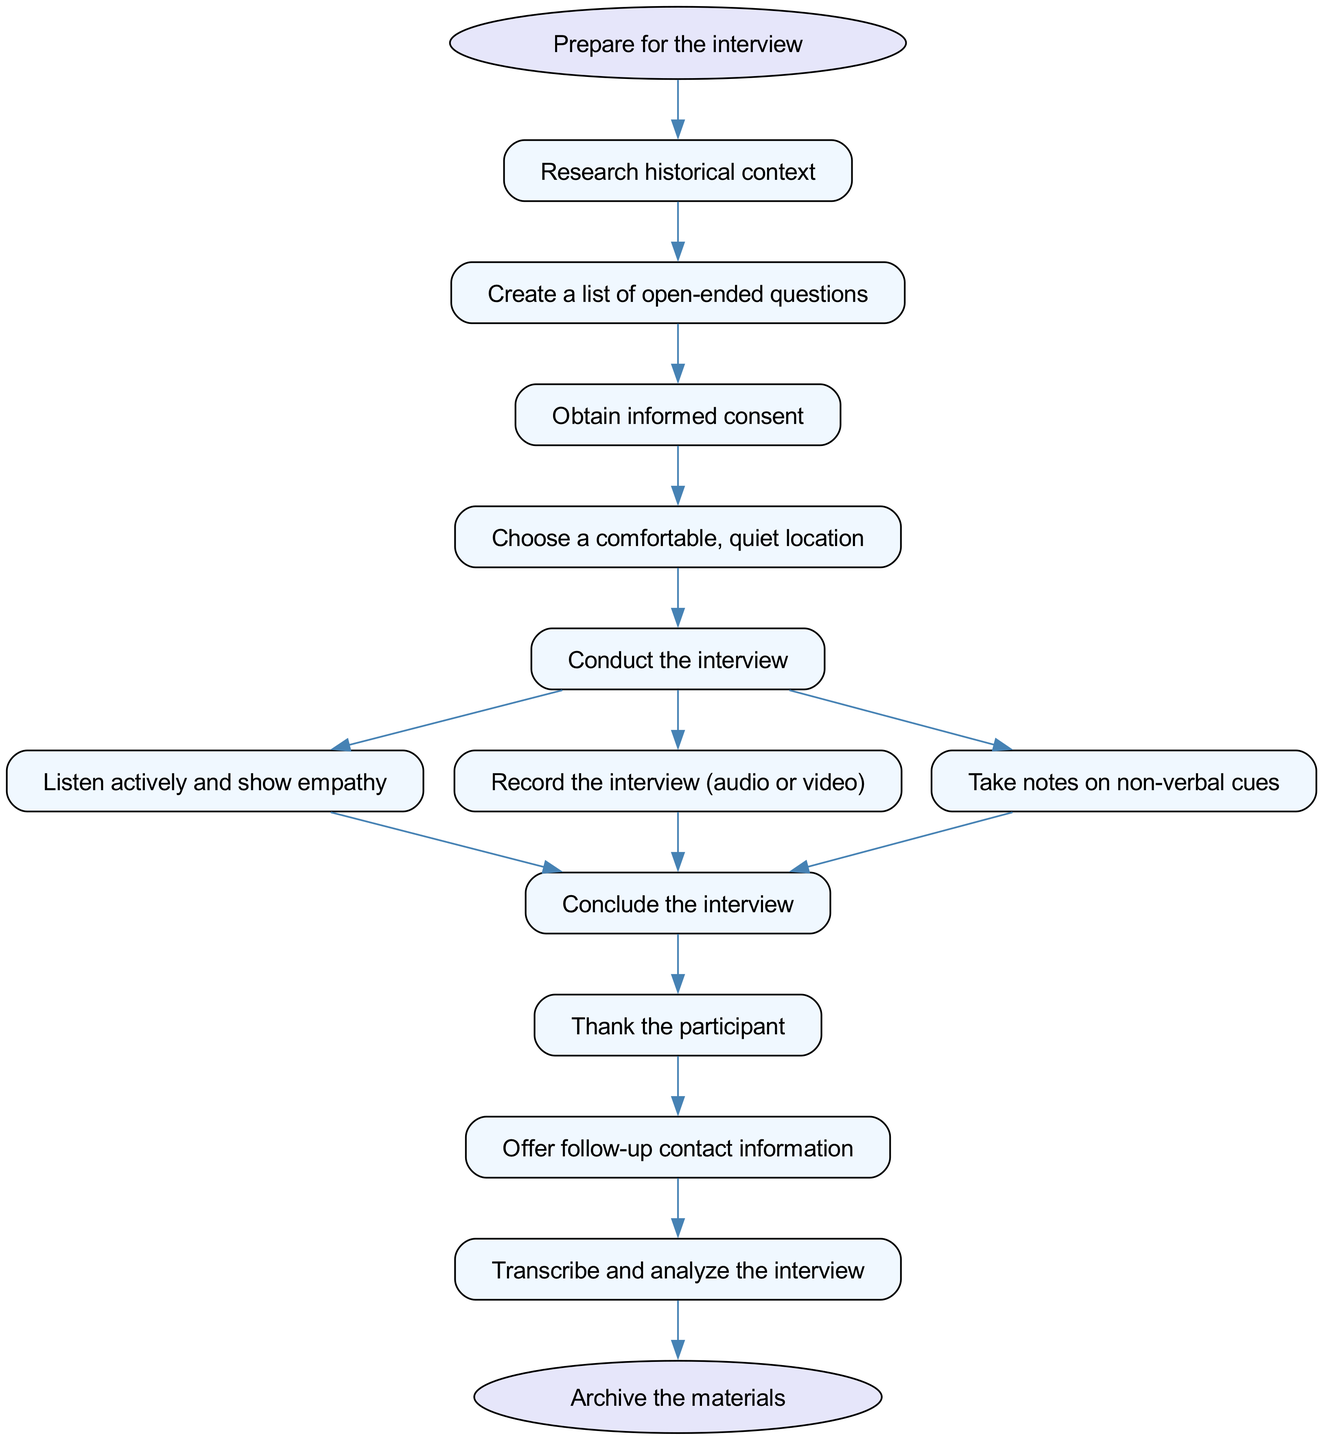What is the first step in the interview process? The diagram shows that the first step after starting is to "Prepare for the interview." Therefore, the initial action is to prepare.
Answer: Prepare for the interview How many nodes are connected directly to "Conduct the interview"? "Conduct the interview" has three direct connections leading to "Listen actively and show empathy," "Record the interview (audio or video)," and "Take notes on non-verbal cues." Counting these gives us three.
Answer: 3 What is required before choosing a location for the interview? According to the diagram, "Obtain informed consent" is the step that must be completed after creating a list of open-ended questions and before choosing a comfortable location. Thus, obtaining consent is the prerequisite.
Answer: Obtain informed consent What is the final step in the interview process? The diagram indicates that the last step is "Archive the materials." This means, after all other actions have been executed, archiving is what needs to be done at the end.
Answer: Archive the materials Which step follows after thanking the participant? The diagram shows that "Offer follow-up contact information" comes directly after "Thank the participant." Therefore, this is the next step that follows.
Answer: Offer follow-up contact information What should be done during the interview to ensure a good interaction? "Listen actively and show empathy" is critical during the interview process as indicated in the diagram, which is essential for a positive interaction.
Answer: Listen actively and show empathy How many total steps are there in the interview process? The diagram reveals a total of 14 steps, including the start and end nodes. The count includes all nodes shown in the flow of the instruction.
Answer: 14 How do the steps "Transcribe and analyze the interview" relate to the end of the process? The diagram indicates that "Transcribe and analyze the interview" is the step that directly leads to the final step, "Archive the materials." This means that this step is essential to complete before archiving.
Answer: Archive the materials 